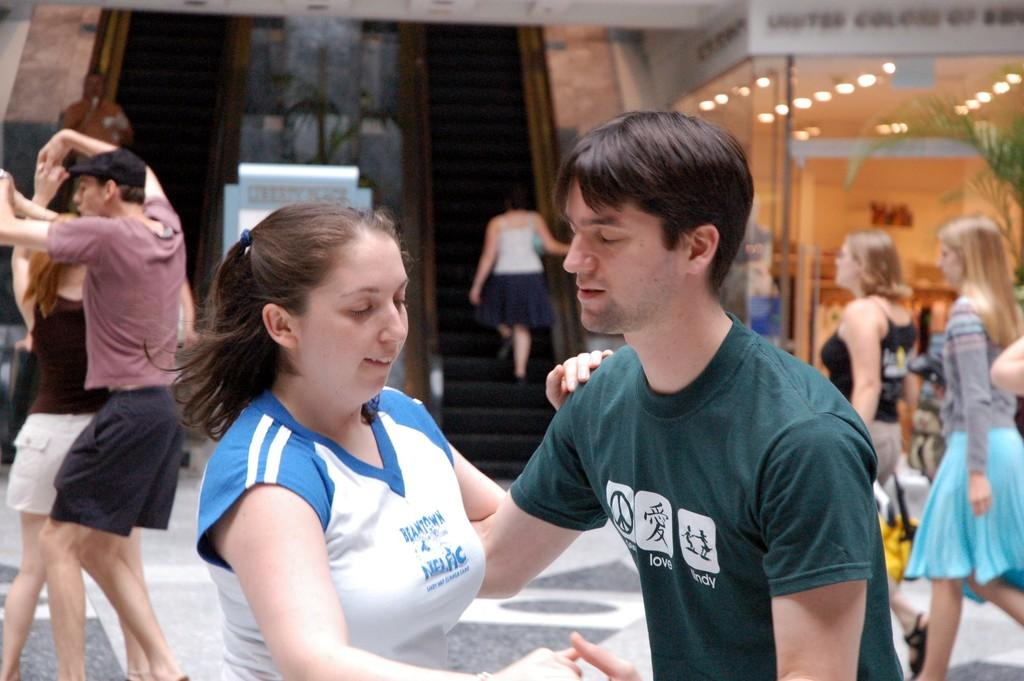How many people are in the image? There is a group of people in the image. What are some of the people in the image doing? Some people are walking. What can be seen in the background of the image? There are lights, plants, and escalators in the background of the image. What is the authority figure in the image doing? There is no authority figure mentioned or visible in the image. the image. What position are the people in the image holding? The image does not provide information about the positions the people are holding. 